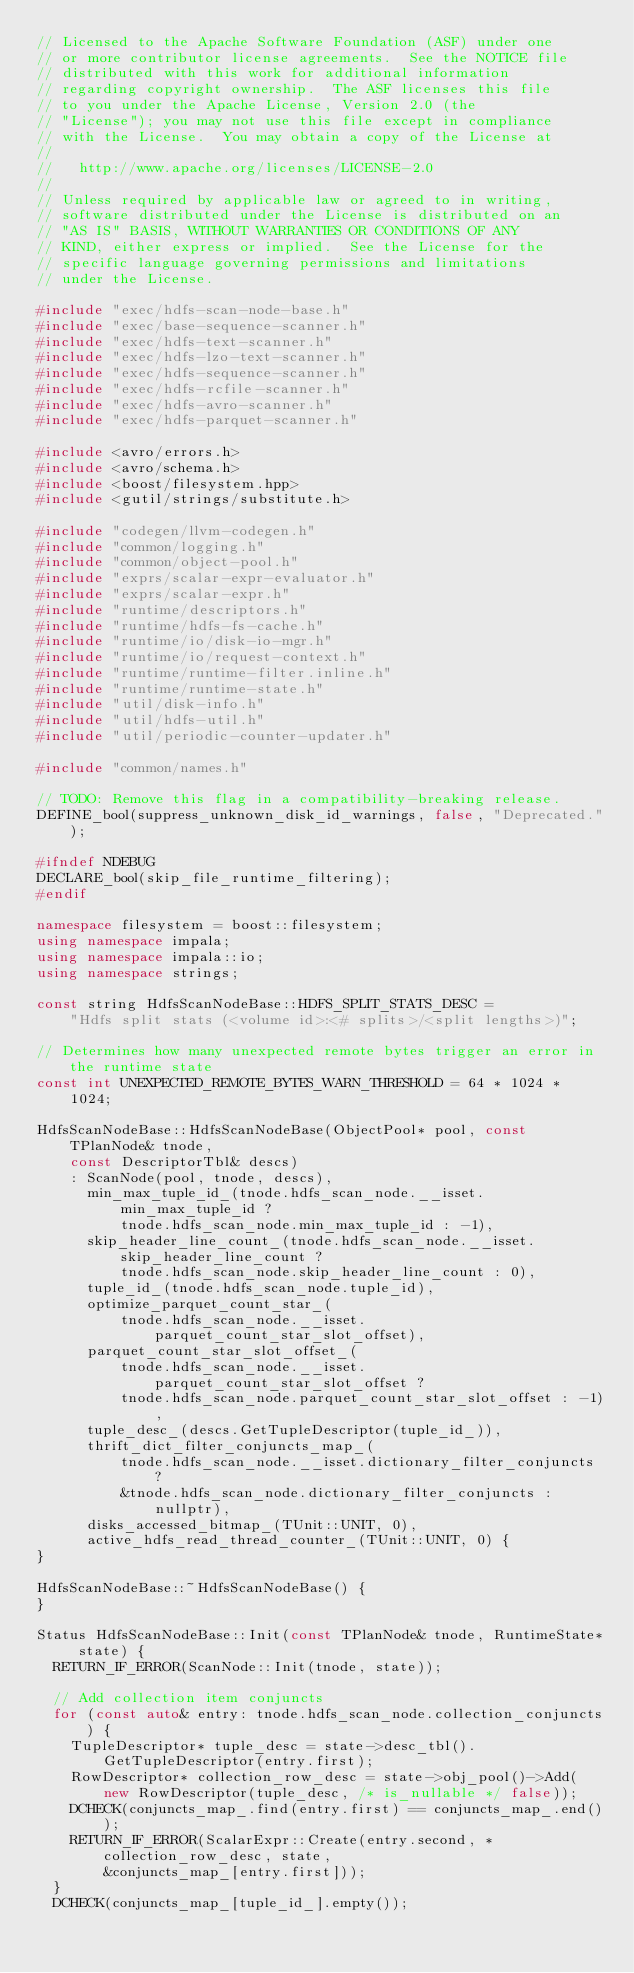Convert code to text. <code><loc_0><loc_0><loc_500><loc_500><_C++_>// Licensed to the Apache Software Foundation (ASF) under one
// or more contributor license agreements.  See the NOTICE file
// distributed with this work for additional information
// regarding copyright ownership.  The ASF licenses this file
// to you under the Apache License, Version 2.0 (the
// "License"); you may not use this file except in compliance
// with the License.  You may obtain a copy of the License at
//
//   http://www.apache.org/licenses/LICENSE-2.0
//
// Unless required by applicable law or agreed to in writing,
// software distributed under the License is distributed on an
// "AS IS" BASIS, WITHOUT WARRANTIES OR CONDITIONS OF ANY
// KIND, either express or implied.  See the License for the
// specific language governing permissions and limitations
// under the License.

#include "exec/hdfs-scan-node-base.h"
#include "exec/base-sequence-scanner.h"
#include "exec/hdfs-text-scanner.h"
#include "exec/hdfs-lzo-text-scanner.h"
#include "exec/hdfs-sequence-scanner.h"
#include "exec/hdfs-rcfile-scanner.h"
#include "exec/hdfs-avro-scanner.h"
#include "exec/hdfs-parquet-scanner.h"

#include <avro/errors.h>
#include <avro/schema.h>
#include <boost/filesystem.hpp>
#include <gutil/strings/substitute.h>

#include "codegen/llvm-codegen.h"
#include "common/logging.h"
#include "common/object-pool.h"
#include "exprs/scalar-expr-evaluator.h"
#include "exprs/scalar-expr.h"
#include "runtime/descriptors.h"
#include "runtime/hdfs-fs-cache.h"
#include "runtime/io/disk-io-mgr.h"
#include "runtime/io/request-context.h"
#include "runtime/runtime-filter.inline.h"
#include "runtime/runtime-state.h"
#include "util/disk-info.h"
#include "util/hdfs-util.h"
#include "util/periodic-counter-updater.h"

#include "common/names.h"

// TODO: Remove this flag in a compatibility-breaking release.
DEFINE_bool(suppress_unknown_disk_id_warnings, false, "Deprecated.");

#ifndef NDEBUG
DECLARE_bool(skip_file_runtime_filtering);
#endif

namespace filesystem = boost::filesystem;
using namespace impala;
using namespace impala::io;
using namespace strings;

const string HdfsScanNodeBase::HDFS_SPLIT_STATS_DESC =
    "Hdfs split stats (<volume id>:<# splits>/<split lengths>)";

// Determines how many unexpected remote bytes trigger an error in the runtime state
const int UNEXPECTED_REMOTE_BYTES_WARN_THRESHOLD = 64 * 1024 * 1024;

HdfsScanNodeBase::HdfsScanNodeBase(ObjectPool* pool, const TPlanNode& tnode,
    const DescriptorTbl& descs)
    : ScanNode(pool, tnode, descs),
      min_max_tuple_id_(tnode.hdfs_scan_node.__isset.min_max_tuple_id ?
          tnode.hdfs_scan_node.min_max_tuple_id : -1),
      skip_header_line_count_(tnode.hdfs_scan_node.__isset.skip_header_line_count ?
          tnode.hdfs_scan_node.skip_header_line_count : 0),
      tuple_id_(tnode.hdfs_scan_node.tuple_id),
      optimize_parquet_count_star_(
          tnode.hdfs_scan_node.__isset.parquet_count_star_slot_offset),
      parquet_count_star_slot_offset_(
          tnode.hdfs_scan_node.__isset.parquet_count_star_slot_offset ?
          tnode.hdfs_scan_node.parquet_count_star_slot_offset : -1),
      tuple_desc_(descs.GetTupleDescriptor(tuple_id_)),
      thrift_dict_filter_conjuncts_map_(
          tnode.hdfs_scan_node.__isset.dictionary_filter_conjuncts ?
          &tnode.hdfs_scan_node.dictionary_filter_conjuncts : nullptr),
      disks_accessed_bitmap_(TUnit::UNIT, 0),
      active_hdfs_read_thread_counter_(TUnit::UNIT, 0) {
}

HdfsScanNodeBase::~HdfsScanNodeBase() {
}

Status HdfsScanNodeBase::Init(const TPlanNode& tnode, RuntimeState* state) {
  RETURN_IF_ERROR(ScanNode::Init(tnode, state));

  // Add collection item conjuncts
  for (const auto& entry: tnode.hdfs_scan_node.collection_conjuncts) {
    TupleDescriptor* tuple_desc = state->desc_tbl().GetTupleDescriptor(entry.first);
    RowDescriptor* collection_row_desc = state->obj_pool()->Add(
        new RowDescriptor(tuple_desc, /* is_nullable */ false));
    DCHECK(conjuncts_map_.find(entry.first) == conjuncts_map_.end());
    RETURN_IF_ERROR(ScalarExpr::Create(entry.second, *collection_row_desc, state,
        &conjuncts_map_[entry.first]));
  }
  DCHECK(conjuncts_map_[tuple_id_].empty());</code> 